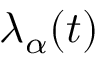<formula> <loc_0><loc_0><loc_500><loc_500>\lambda _ { \alpha } ( t )</formula> 